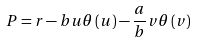<formula> <loc_0><loc_0><loc_500><loc_500>P = r - b u \theta \left ( u \right ) - \frac { a } { b } v \theta \left ( v \right )</formula> 